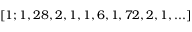Convert formula to latex. <formula><loc_0><loc_0><loc_500><loc_500>[ 1 ; 1 , 2 8 , 2 , 1 , 1 , 6 , 1 , 7 2 , 2 , 1 , \dots ]</formula> 